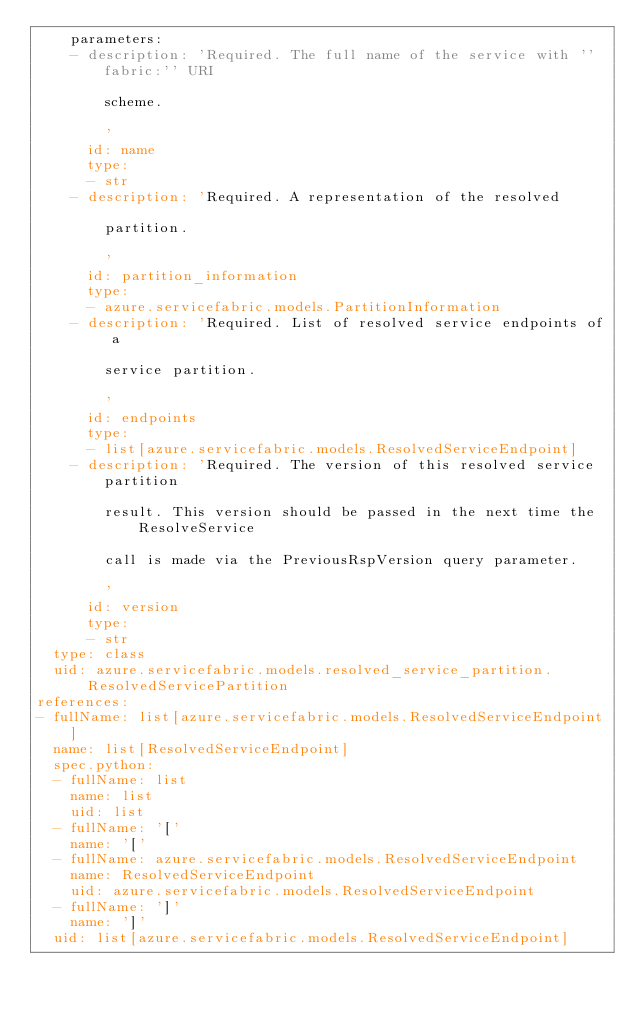<code> <loc_0><loc_0><loc_500><loc_500><_YAML_>    parameters:
    - description: 'Required. The full name of the service with ''fabric:'' URI

        scheme.

        '
      id: name
      type:
      - str
    - description: 'Required. A representation of the resolved

        partition.

        '
      id: partition_information
      type:
      - azure.servicefabric.models.PartitionInformation
    - description: 'Required. List of resolved service endpoints of a

        service partition.

        '
      id: endpoints
      type:
      - list[azure.servicefabric.models.ResolvedServiceEndpoint]
    - description: 'Required. The version of this resolved service partition

        result. This version should be passed in the next time the ResolveService

        call is made via the PreviousRspVersion query parameter.

        '
      id: version
      type:
      - str
  type: class
  uid: azure.servicefabric.models.resolved_service_partition.ResolvedServicePartition
references:
- fullName: list[azure.servicefabric.models.ResolvedServiceEndpoint]
  name: list[ResolvedServiceEndpoint]
  spec.python:
  - fullName: list
    name: list
    uid: list
  - fullName: '['
    name: '['
  - fullName: azure.servicefabric.models.ResolvedServiceEndpoint
    name: ResolvedServiceEndpoint
    uid: azure.servicefabric.models.ResolvedServiceEndpoint
  - fullName: ']'
    name: ']'
  uid: list[azure.servicefabric.models.ResolvedServiceEndpoint]
</code> 